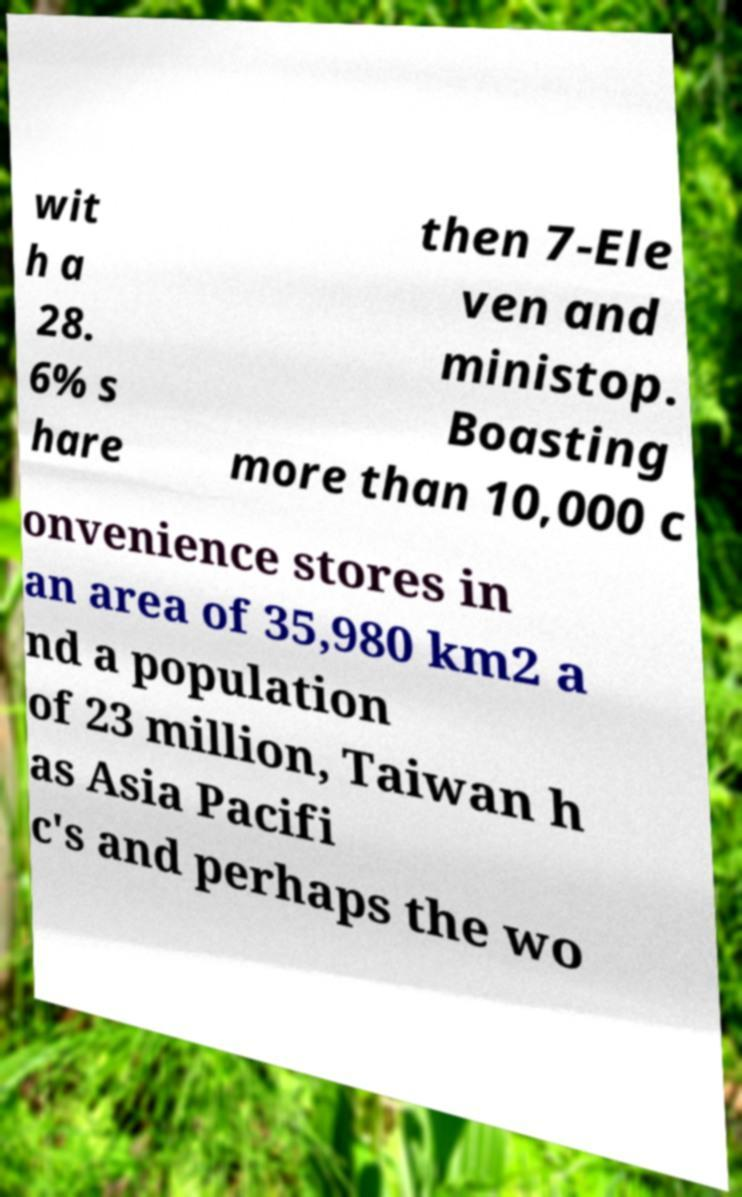Could you assist in decoding the text presented in this image and type it out clearly? wit h a 28. 6% s hare then 7-Ele ven and ministop. Boasting more than 10,000 c onvenience stores in an area of 35,980 km2 a nd a population of 23 million, Taiwan h as Asia Pacifi c's and perhaps the wo 